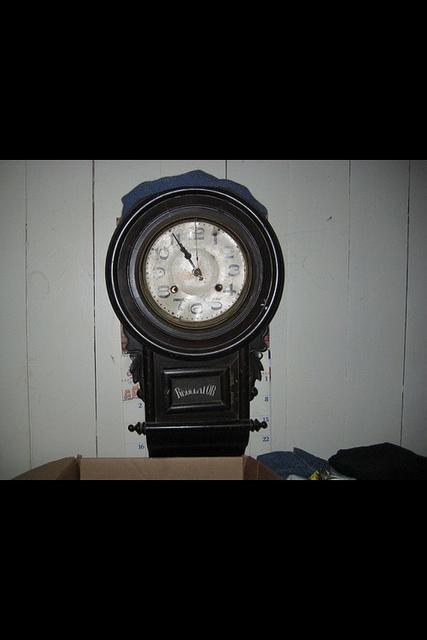What time is it?
Quick response, please. 11. Can you wear this on your wrist?
Concise answer only. No. Are there Roman numerals on the clock face?
Concise answer only. No. IS IT 30 PAST 4:00?
Concise answer only. No. Is it am or pm?
Give a very brief answer. Pm. 